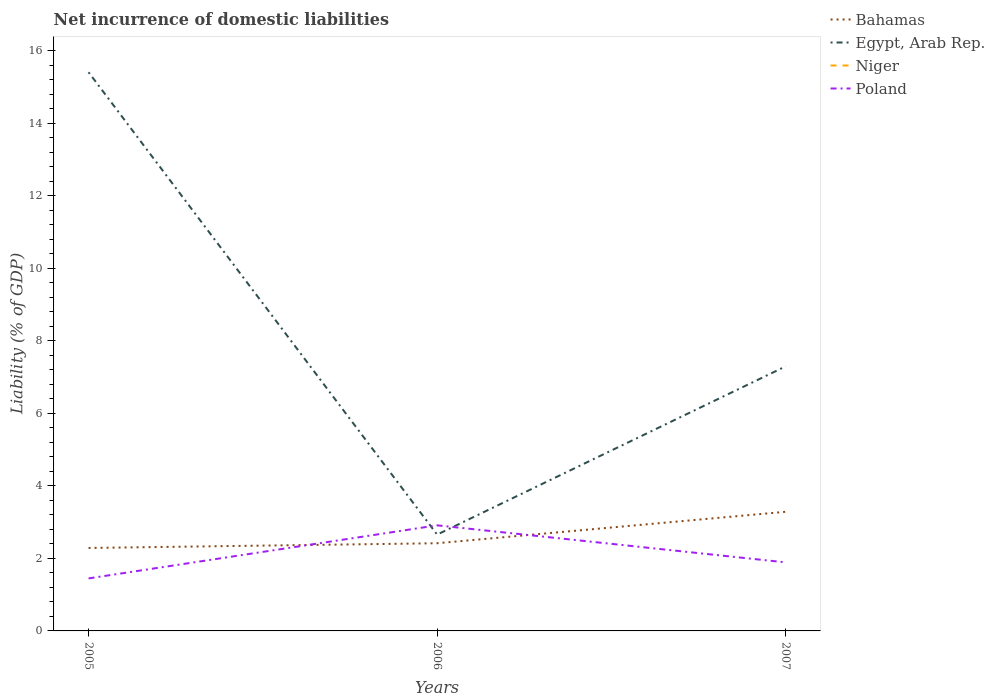Across all years, what is the maximum net incurrence of domestic liabilities in Bahamas?
Provide a short and direct response. 2.29. What is the total net incurrence of domestic liabilities in Poland in the graph?
Your answer should be compact. 1.02. What is the difference between the highest and the second highest net incurrence of domestic liabilities in Bahamas?
Provide a succinct answer. 1. How many lines are there?
Provide a succinct answer. 3. Are the values on the major ticks of Y-axis written in scientific E-notation?
Your answer should be very brief. No. Does the graph contain grids?
Offer a very short reply. No. What is the title of the graph?
Offer a very short reply. Net incurrence of domestic liabilities. What is the label or title of the Y-axis?
Provide a succinct answer. Liability (% of GDP). What is the Liability (% of GDP) in Bahamas in 2005?
Your answer should be compact. 2.29. What is the Liability (% of GDP) of Egypt, Arab Rep. in 2005?
Keep it short and to the point. 15.41. What is the Liability (% of GDP) of Poland in 2005?
Your response must be concise. 1.45. What is the Liability (% of GDP) of Bahamas in 2006?
Your answer should be compact. 2.42. What is the Liability (% of GDP) of Egypt, Arab Rep. in 2006?
Your answer should be very brief. 2.66. What is the Liability (% of GDP) of Poland in 2006?
Give a very brief answer. 2.91. What is the Liability (% of GDP) in Bahamas in 2007?
Give a very brief answer. 3.29. What is the Liability (% of GDP) of Egypt, Arab Rep. in 2007?
Your answer should be compact. 7.3. What is the Liability (% of GDP) in Poland in 2007?
Give a very brief answer. 1.89. Across all years, what is the maximum Liability (% of GDP) in Bahamas?
Offer a terse response. 3.29. Across all years, what is the maximum Liability (% of GDP) of Egypt, Arab Rep.?
Your answer should be compact. 15.41. Across all years, what is the maximum Liability (% of GDP) of Poland?
Provide a succinct answer. 2.91. Across all years, what is the minimum Liability (% of GDP) in Bahamas?
Give a very brief answer. 2.29. Across all years, what is the minimum Liability (% of GDP) in Egypt, Arab Rep.?
Your response must be concise. 2.66. Across all years, what is the minimum Liability (% of GDP) of Poland?
Your answer should be compact. 1.45. What is the total Liability (% of GDP) in Bahamas in the graph?
Offer a very short reply. 7.99. What is the total Liability (% of GDP) in Egypt, Arab Rep. in the graph?
Ensure brevity in your answer.  25.36. What is the total Liability (% of GDP) of Niger in the graph?
Your answer should be compact. 0. What is the total Liability (% of GDP) of Poland in the graph?
Ensure brevity in your answer.  6.25. What is the difference between the Liability (% of GDP) in Bahamas in 2005 and that in 2006?
Your answer should be compact. -0.13. What is the difference between the Liability (% of GDP) of Egypt, Arab Rep. in 2005 and that in 2006?
Make the answer very short. 12.75. What is the difference between the Liability (% of GDP) of Poland in 2005 and that in 2006?
Your response must be concise. -1.46. What is the difference between the Liability (% of GDP) of Bahamas in 2005 and that in 2007?
Ensure brevity in your answer.  -1. What is the difference between the Liability (% of GDP) of Egypt, Arab Rep. in 2005 and that in 2007?
Your response must be concise. 8.11. What is the difference between the Liability (% of GDP) in Poland in 2005 and that in 2007?
Offer a terse response. -0.44. What is the difference between the Liability (% of GDP) of Bahamas in 2006 and that in 2007?
Offer a very short reply. -0.87. What is the difference between the Liability (% of GDP) in Egypt, Arab Rep. in 2006 and that in 2007?
Provide a succinct answer. -4.64. What is the difference between the Liability (% of GDP) in Poland in 2006 and that in 2007?
Make the answer very short. 1.02. What is the difference between the Liability (% of GDP) in Bahamas in 2005 and the Liability (% of GDP) in Egypt, Arab Rep. in 2006?
Offer a very short reply. -0.37. What is the difference between the Liability (% of GDP) in Bahamas in 2005 and the Liability (% of GDP) in Poland in 2006?
Offer a terse response. -0.62. What is the difference between the Liability (% of GDP) in Egypt, Arab Rep. in 2005 and the Liability (% of GDP) in Poland in 2006?
Make the answer very short. 12.5. What is the difference between the Liability (% of GDP) in Bahamas in 2005 and the Liability (% of GDP) in Egypt, Arab Rep. in 2007?
Your answer should be compact. -5.01. What is the difference between the Liability (% of GDP) of Bahamas in 2005 and the Liability (% of GDP) of Poland in 2007?
Offer a terse response. 0.4. What is the difference between the Liability (% of GDP) in Egypt, Arab Rep. in 2005 and the Liability (% of GDP) in Poland in 2007?
Your response must be concise. 13.52. What is the difference between the Liability (% of GDP) in Bahamas in 2006 and the Liability (% of GDP) in Egypt, Arab Rep. in 2007?
Your answer should be very brief. -4.88. What is the difference between the Liability (% of GDP) of Bahamas in 2006 and the Liability (% of GDP) of Poland in 2007?
Provide a succinct answer. 0.53. What is the difference between the Liability (% of GDP) of Egypt, Arab Rep. in 2006 and the Liability (% of GDP) of Poland in 2007?
Ensure brevity in your answer.  0.77. What is the average Liability (% of GDP) of Bahamas per year?
Offer a very short reply. 2.66. What is the average Liability (% of GDP) in Egypt, Arab Rep. per year?
Keep it short and to the point. 8.45. What is the average Liability (% of GDP) of Niger per year?
Provide a succinct answer. 0. What is the average Liability (% of GDP) in Poland per year?
Your answer should be compact. 2.08. In the year 2005, what is the difference between the Liability (% of GDP) of Bahamas and Liability (% of GDP) of Egypt, Arab Rep.?
Keep it short and to the point. -13.12. In the year 2005, what is the difference between the Liability (% of GDP) of Bahamas and Liability (% of GDP) of Poland?
Your answer should be compact. 0.84. In the year 2005, what is the difference between the Liability (% of GDP) of Egypt, Arab Rep. and Liability (% of GDP) of Poland?
Your response must be concise. 13.96. In the year 2006, what is the difference between the Liability (% of GDP) of Bahamas and Liability (% of GDP) of Egypt, Arab Rep.?
Your response must be concise. -0.24. In the year 2006, what is the difference between the Liability (% of GDP) of Bahamas and Liability (% of GDP) of Poland?
Offer a terse response. -0.49. In the year 2006, what is the difference between the Liability (% of GDP) of Egypt, Arab Rep. and Liability (% of GDP) of Poland?
Provide a short and direct response. -0.26. In the year 2007, what is the difference between the Liability (% of GDP) in Bahamas and Liability (% of GDP) in Egypt, Arab Rep.?
Your response must be concise. -4.01. In the year 2007, what is the difference between the Liability (% of GDP) of Bahamas and Liability (% of GDP) of Poland?
Offer a very short reply. 1.4. In the year 2007, what is the difference between the Liability (% of GDP) in Egypt, Arab Rep. and Liability (% of GDP) in Poland?
Your answer should be compact. 5.41. What is the ratio of the Liability (% of GDP) of Bahamas in 2005 to that in 2006?
Your answer should be very brief. 0.95. What is the ratio of the Liability (% of GDP) in Egypt, Arab Rep. in 2005 to that in 2006?
Provide a short and direct response. 5.8. What is the ratio of the Liability (% of GDP) of Poland in 2005 to that in 2006?
Offer a terse response. 0.5. What is the ratio of the Liability (% of GDP) of Bahamas in 2005 to that in 2007?
Provide a short and direct response. 0.7. What is the ratio of the Liability (% of GDP) of Egypt, Arab Rep. in 2005 to that in 2007?
Provide a short and direct response. 2.11. What is the ratio of the Liability (% of GDP) in Poland in 2005 to that in 2007?
Give a very brief answer. 0.77. What is the ratio of the Liability (% of GDP) in Bahamas in 2006 to that in 2007?
Provide a short and direct response. 0.74. What is the ratio of the Liability (% of GDP) in Egypt, Arab Rep. in 2006 to that in 2007?
Your answer should be compact. 0.36. What is the ratio of the Liability (% of GDP) in Poland in 2006 to that in 2007?
Keep it short and to the point. 1.54. What is the difference between the highest and the second highest Liability (% of GDP) of Bahamas?
Give a very brief answer. 0.87. What is the difference between the highest and the second highest Liability (% of GDP) in Egypt, Arab Rep.?
Your answer should be compact. 8.11. What is the difference between the highest and the second highest Liability (% of GDP) of Poland?
Offer a terse response. 1.02. What is the difference between the highest and the lowest Liability (% of GDP) in Bahamas?
Keep it short and to the point. 1. What is the difference between the highest and the lowest Liability (% of GDP) in Egypt, Arab Rep.?
Make the answer very short. 12.75. What is the difference between the highest and the lowest Liability (% of GDP) of Poland?
Ensure brevity in your answer.  1.46. 